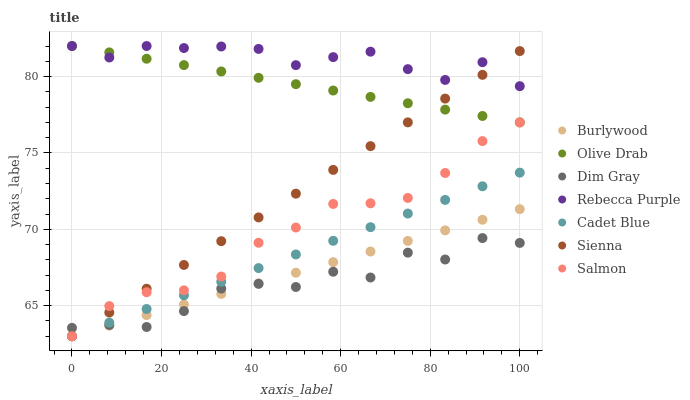Does Dim Gray have the minimum area under the curve?
Answer yes or no. Yes. Does Rebecca Purple have the maximum area under the curve?
Answer yes or no. Yes. Does Burlywood have the minimum area under the curve?
Answer yes or no. No. Does Burlywood have the maximum area under the curve?
Answer yes or no. No. Is Olive Drab the smoothest?
Answer yes or no. Yes. Is Dim Gray the roughest?
Answer yes or no. Yes. Is Burlywood the smoothest?
Answer yes or no. No. Is Burlywood the roughest?
Answer yes or no. No. Does Burlywood have the lowest value?
Answer yes or no. Yes. Does Rebecca Purple have the lowest value?
Answer yes or no. No. Does Olive Drab have the highest value?
Answer yes or no. Yes. Does Burlywood have the highest value?
Answer yes or no. No. Is Salmon less than Rebecca Purple?
Answer yes or no. Yes. Is Rebecca Purple greater than Burlywood?
Answer yes or no. Yes. Does Cadet Blue intersect Dim Gray?
Answer yes or no. Yes. Is Cadet Blue less than Dim Gray?
Answer yes or no. No. Is Cadet Blue greater than Dim Gray?
Answer yes or no. No. Does Salmon intersect Rebecca Purple?
Answer yes or no. No. 